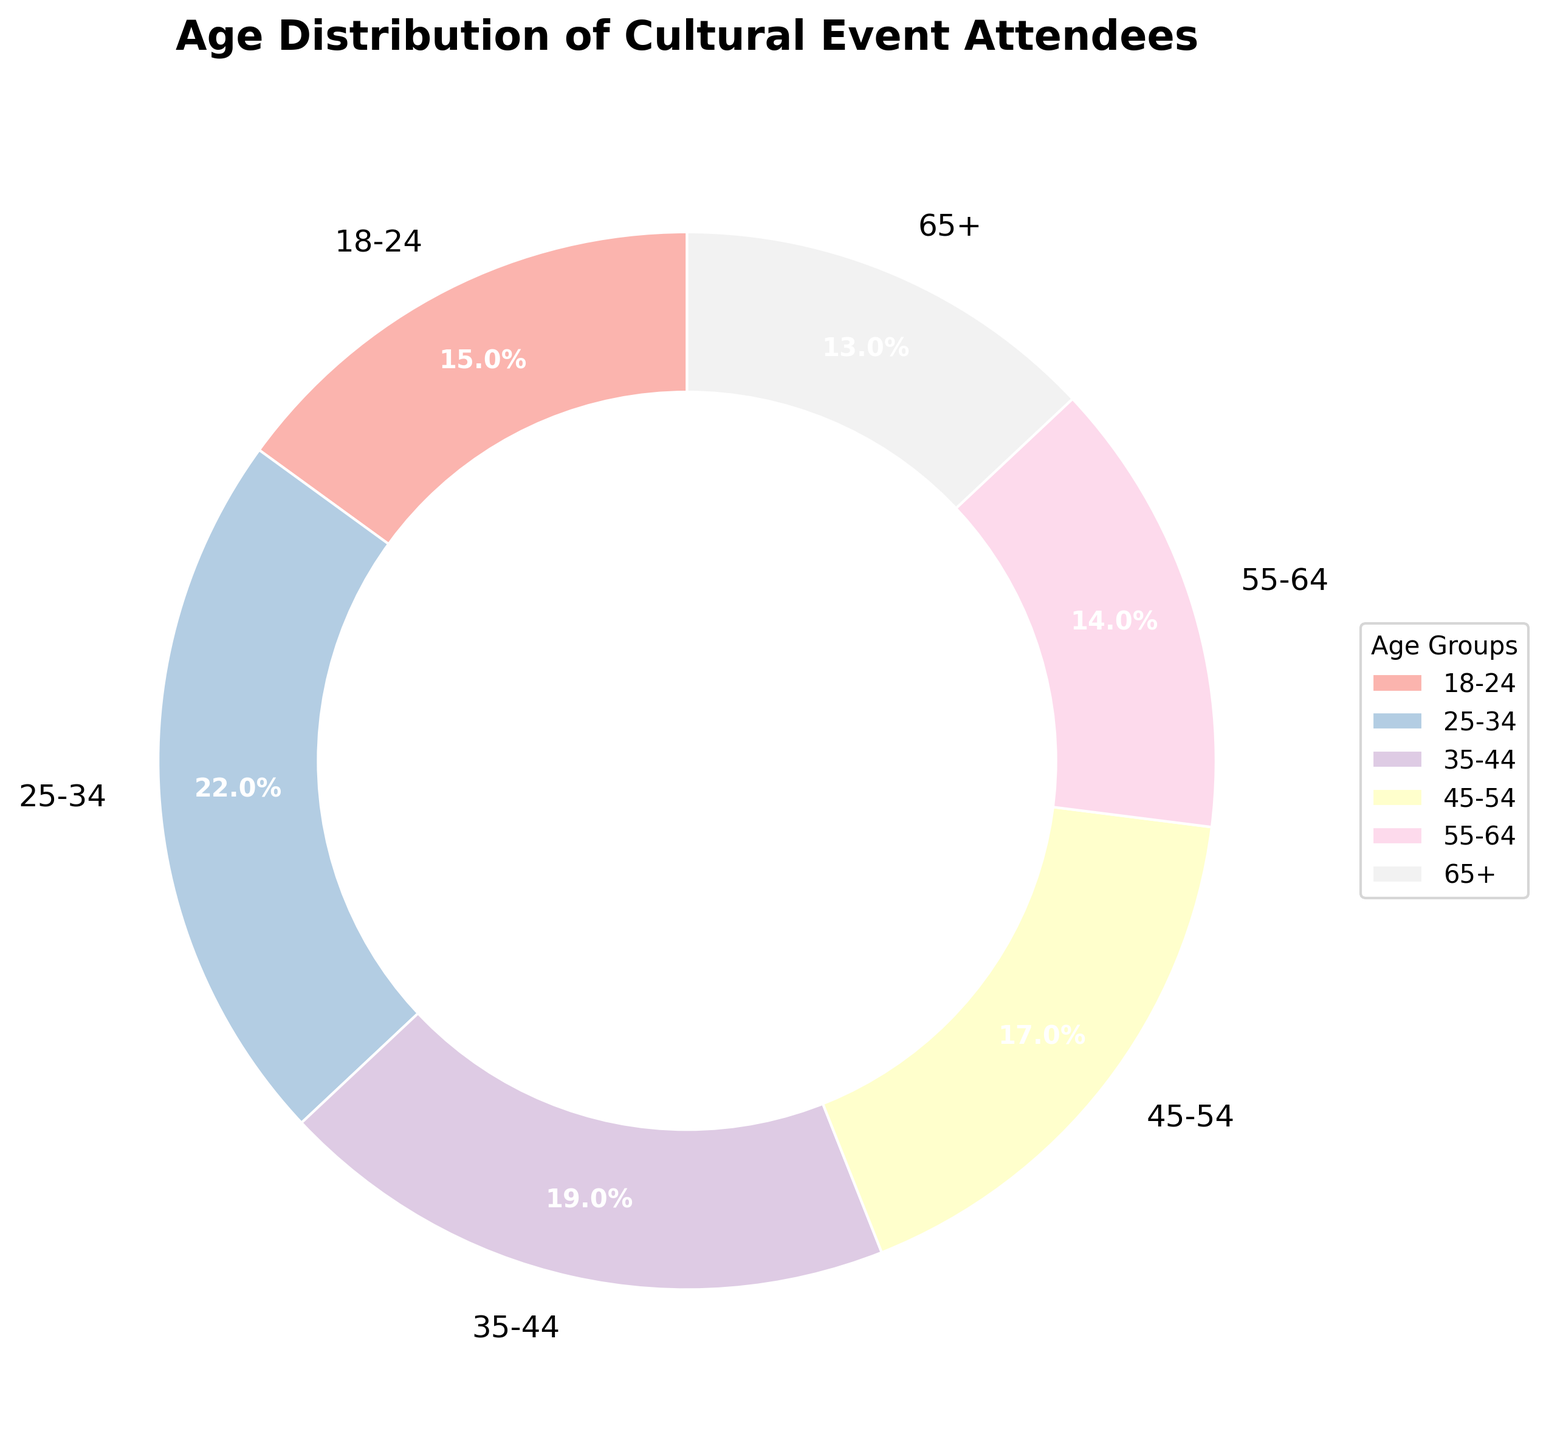What percentage of attendees are aged 35-44? Identify the slice labeled '35-44' in the pie chart and read off the corresponding percentage, which is 19%.
Answer: 19% Which age group has the highest percentage of attendees? Among the slices, '25-34' has the largest area covered, indicating it has the highest percentage at 22%.
Answer: 25-34 What is the total percentage of attendees aged between 25 and 44? Sum the percentages of the age groups '25-34' and '35-44', which are 22% and 19%, respectively. 22 + 19 = 41%.
Answer: 41% How does the percentage of attendees aged 18-24 compare to those aged 65+? Compare the slices labeled '18-24' and '65+'. The percentage for '18-24' is 15%, and for '65+' it is 13%. Since 15 is greater than 13, the '18-24' group has a higher percentage.
Answer: Greater What is the difference in attendee percentage between the 45-54 and 55-64 age groups? Subtract the percentage of '55-64' from '45-54'. The percentages are 17% for '45-54' and 14% for '55-64'. 17 - 14 = 3%.
Answer: 3% Which age group occupies the smallest slice of the pie? Identify the smallest slice in the pie chart, which corresponds to the '65+' age group with 13%.
Answer: 65+ Compare the combined percentage of attendees aged under 35 (18-24 and 25-34) with those aged 35 and above. Is it higher or lower? Calculate the sum of percentages for '18-24' and '25-34': 15 + 22 = 37%. Calculate the sum for other age groups: 19 + 17 + 14 + 13 = 63%. Since 37% is less than 63%, the combined percentage for the younger group is lower.
Answer: Lower What are the color shades used for the 25-34 and 55-64 age groups? The '25-34' group is depicted in the second lightest shade, and the '55-64' group in the fifth shade, both using pastel colors. Describe the specific colors if visible hues are distinguishable.
Answer: Pastel shades Calculate the average percentage of attendees for all age groups. Sum all percentages: 15 + 22 + 19 + 17 + 14 + 13 = 100. Divide by the number of groups (6): 100 / 6 ≈ 16.67%.
Answer: 16.67% Are the slices for the 35-44 and 45-54 age groups visually distinguishable in size? Compare the visual areas of the '35-44' and '45-54' slices. The difference is small but visible, as 19% is slightly larger than 17%.
Answer: Yes 